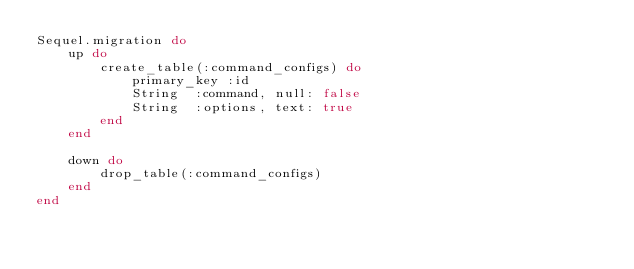<code> <loc_0><loc_0><loc_500><loc_500><_Ruby_>Sequel.migration do
    up do
        create_table(:command_configs) do
            primary_key :id
            String  :command, null: false
            String  :options, text: true
        end
    end

    down do
        drop_table(:command_configs)
    end
end
</code> 